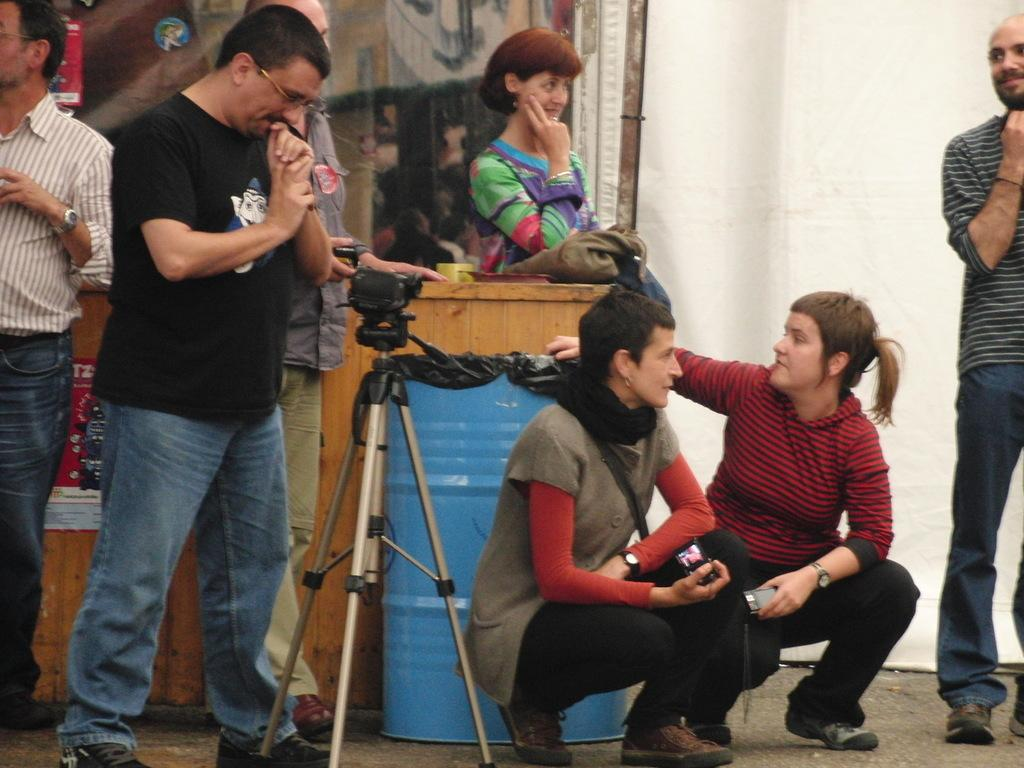What is the main subject of the image? The main subject of the image is a group of people on the ground. What objects are related to photography in the image? There is a tripod stand and a camera present in the image. What musical instrument can be seen in the image? There is a drum in the image. What type of decorations or signs are visible in the image? Posters are visible in the image. What is in the background of the image? There is a wall in the background of the image. What type of pain is the group of people experiencing in the image? There is no indication of pain in the image; the group of people appears to be engaged in an activity or gathering. What discovery was made by the creator of the drum in the image? There is no information about the creator of the drum or any discoveries made in the image. 